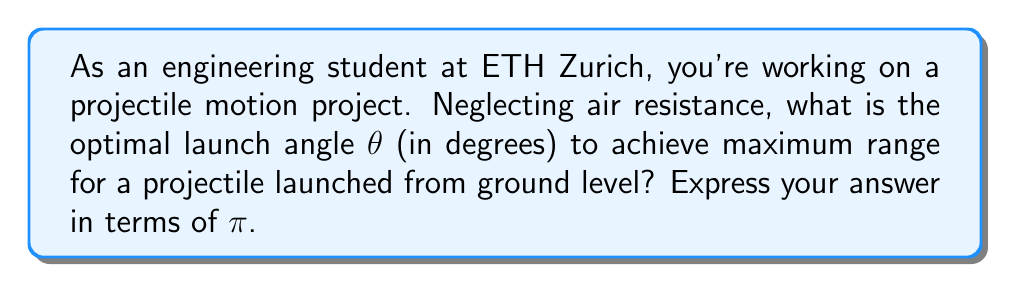Could you help me with this problem? Let's approach this step-by-step:

1) The range R of a projectile launched with initial velocity v₀ at an angle θ to the horizontal is given by:

   $$R = \frac{v_0^2 \sin(2\theta)}{g}$$

   where g is the acceleration due to gravity.

2) To find the maximum range, we need to maximize sin(2θ).

3) The sine function reaches its maximum value of 1 when its argument is 90°, or π/2 radians.

4) Therefore, for maximum range:

   $$2\theta = \frac{\pi}{2}$$

5) Solving for θ:

   $$\theta = \frac{\pi}{4}$$

6) Converting to degrees:

   $$\theta = \frac{\pi}{4} \cdot \frac{180°}{\pi} = 45°$$

7) This result makes intuitive sense: launching at 45° balances the trade-off between horizontal distance and time in the air.
Answer: $\frac{\pi}{4}$ radians or 45° 